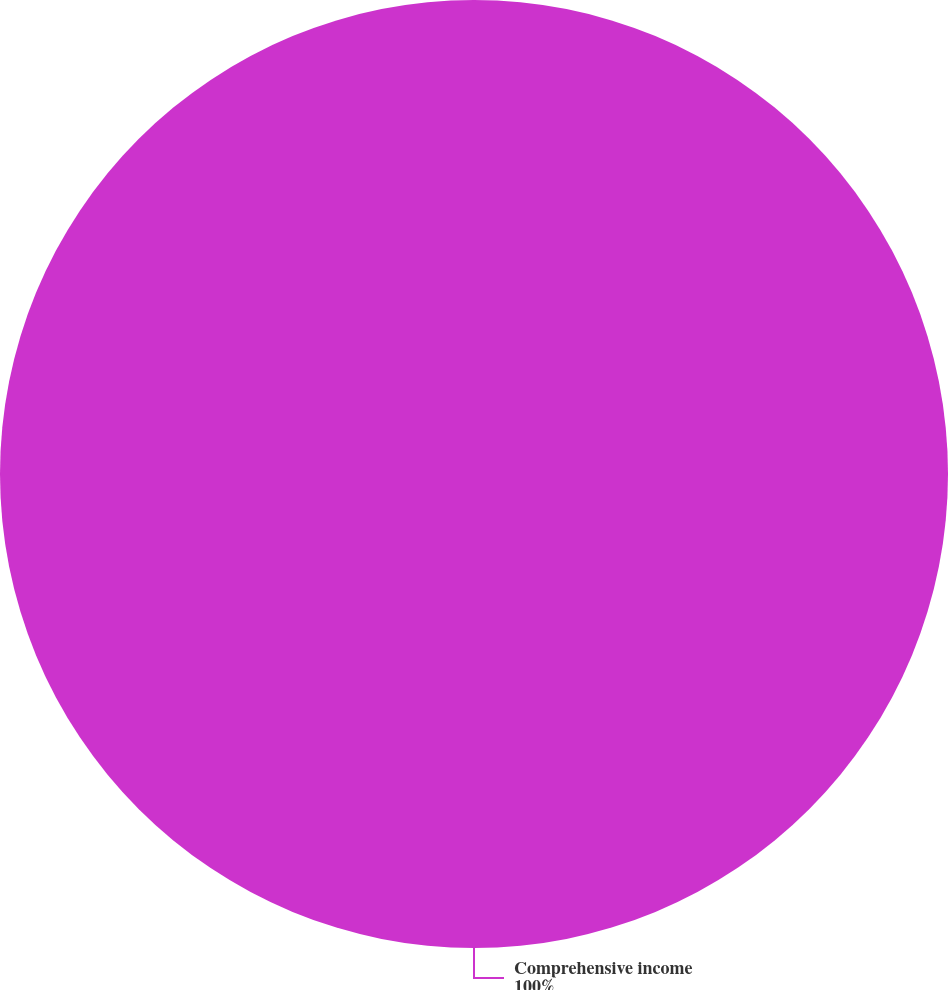Convert chart to OTSL. <chart><loc_0><loc_0><loc_500><loc_500><pie_chart><fcel>Comprehensive income<nl><fcel>100.0%<nl></chart> 